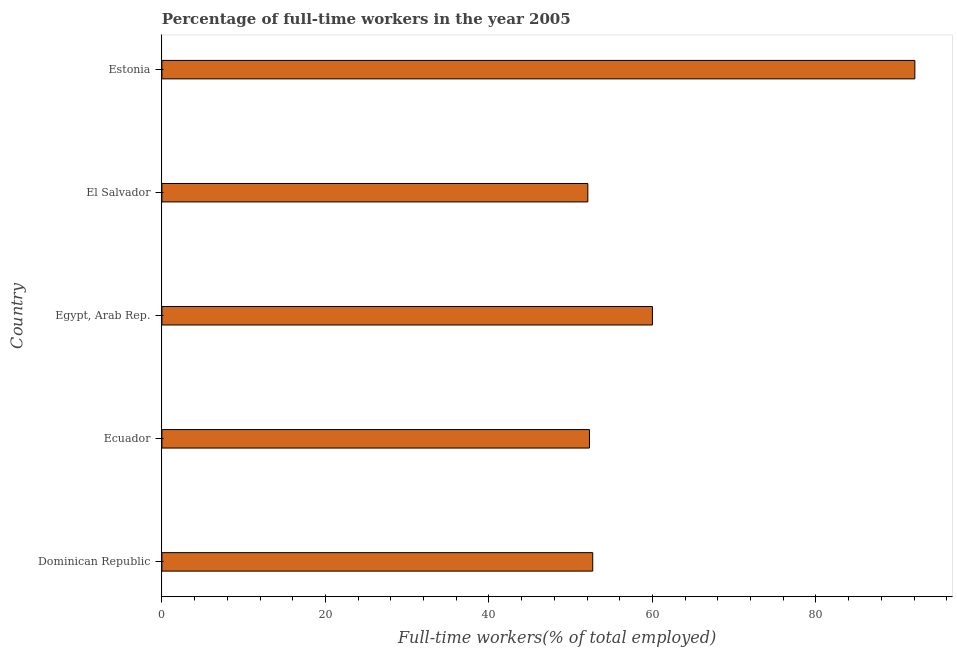Does the graph contain grids?
Give a very brief answer. No. What is the title of the graph?
Offer a very short reply. Percentage of full-time workers in the year 2005. What is the label or title of the X-axis?
Offer a very short reply. Full-time workers(% of total employed). What is the percentage of full-time workers in Estonia?
Your answer should be compact. 92.1. Across all countries, what is the maximum percentage of full-time workers?
Give a very brief answer. 92.1. Across all countries, what is the minimum percentage of full-time workers?
Keep it short and to the point. 52.1. In which country was the percentage of full-time workers maximum?
Ensure brevity in your answer.  Estonia. In which country was the percentage of full-time workers minimum?
Offer a very short reply. El Salvador. What is the sum of the percentage of full-time workers?
Keep it short and to the point. 309.2. What is the average percentage of full-time workers per country?
Provide a succinct answer. 61.84. What is the median percentage of full-time workers?
Ensure brevity in your answer.  52.7. In how many countries, is the percentage of full-time workers greater than 76 %?
Make the answer very short. 1. What is the ratio of the percentage of full-time workers in Egypt, Arab Rep. to that in El Salvador?
Keep it short and to the point. 1.15. Is the percentage of full-time workers in Dominican Republic less than that in Egypt, Arab Rep.?
Ensure brevity in your answer.  Yes. What is the difference between the highest and the second highest percentage of full-time workers?
Your response must be concise. 32.1. What is the difference between the highest and the lowest percentage of full-time workers?
Give a very brief answer. 40. In how many countries, is the percentage of full-time workers greater than the average percentage of full-time workers taken over all countries?
Give a very brief answer. 1. Are all the bars in the graph horizontal?
Ensure brevity in your answer.  Yes. What is the Full-time workers(% of total employed) in Dominican Republic?
Provide a succinct answer. 52.7. What is the Full-time workers(% of total employed) in Ecuador?
Offer a very short reply. 52.3. What is the Full-time workers(% of total employed) of El Salvador?
Provide a succinct answer. 52.1. What is the Full-time workers(% of total employed) in Estonia?
Give a very brief answer. 92.1. What is the difference between the Full-time workers(% of total employed) in Dominican Republic and Ecuador?
Provide a short and direct response. 0.4. What is the difference between the Full-time workers(% of total employed) in Dominican Republic and Egypt, Arab Rep.?
Make the answer very short. -7.3. What is the difference between the Full-time workers(% of total employed) in Dominican Republic and El Salvador?
Your response must be concise. 0.6. What is the difference between the Full-time workers(% of total employed) in Dominican Republic and Estonia?
Give a very brief answer. -39.4. What is the difference between the Full-time workers(% of total employed) in Ecuador and Estonia?
Offer a terse response. -39.8. What is the difference between the Full-time workers(% of total employed) in Egypt, Arab Rep. and Estonia?
Offer a very short reply. -32.1. What is the difference between the Full-time workers(% of total employed) in El Salvador and Estonia?
Your response must be concise. -40. What is the ratio of the Full-time workers(% of total employed) in Dominican Republic to that in Egypt, Arab Rep.?
Offer a terse response. 0.88. What is the ratio of the Full-time workers(% of total employed) in Dominican Republic to that in Estonia?
Provide a succinct answer. 0.57. What is the ratio of the Full-time workers(% of total employed) in Ecuador to that in Egypt, Arab Rep.?
Make the answer very short. 0.87. What is the ratio of the Full-time workers(% of total employed) in Ecuador to that in Estonia?
Offer a very short reply. 0.57. What is the ratio of the Full-time workers(% of total employed) in Egypt, Arab Rep. to that in El Salvador?
Offer a very short reply. 1.15. What is the ratio of the Full-time workers(% of total employed) in Egypt, Arab Rep. to that in Estonia?
Keep it short and to the point. 0.65. What is the ratio of the Full-time workers(% of total employed) in El Salvador to that in Estonia?
Your response must be concise. 0.57. 